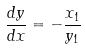<formula> <loc_0><loc_0><loc_500><loc_500>\frac { d y } { d x } = - \frac { x _ { 1 } } { y _ { 1 } }</formula> 